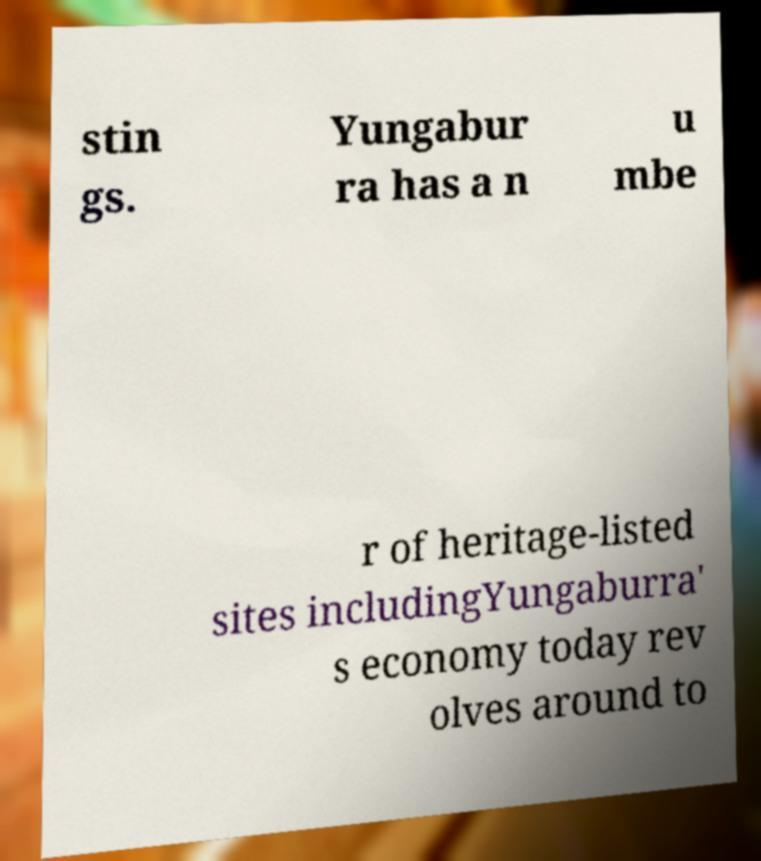Can you read and provide the text displayed in the image?This photo seems to have some interesting text. Can you extract and type it out for me? stin gs. Yungabur ra has a n u mbe r of heritage-listed sites includingYungaburra' s economy today rev olves around to 